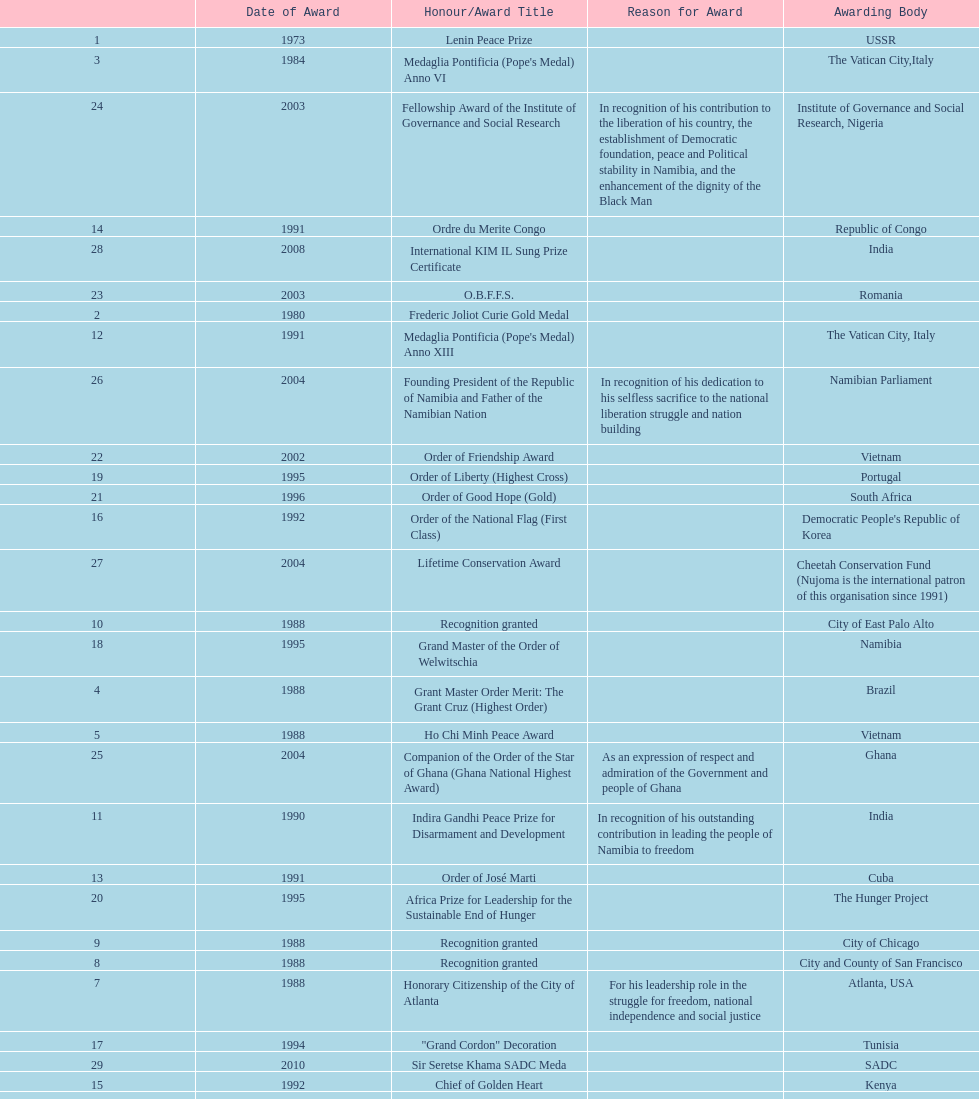What is the last honors/award title listed on this chart? Sir Seretse Khama SADC Meda. 